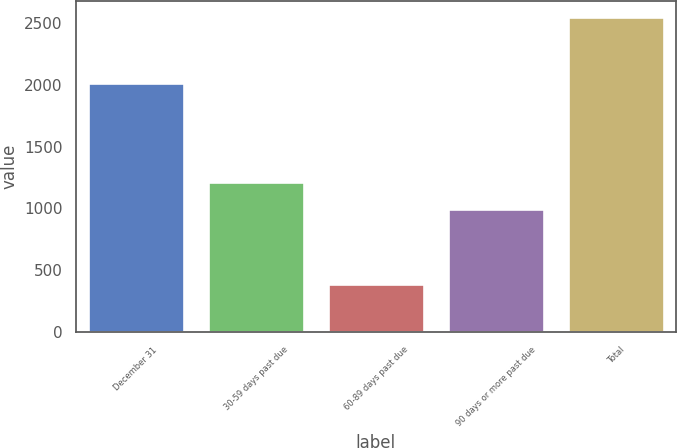<chart> <loc_0><loc_0><loc_500><loc_500><bar_chart><fcel>December 31<fcel>30-59 days past due<fcel>60-89 days past due<fcel>90 days or more past due<fcel>Total<nl><fcel>2017<fcel>1211.2<fcel>385<fcel>995<fcel>2547<nl></chart> 